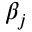Convert formula to latex. <formula><loc_0><loc_0><loc_500><loc_500>\beta _ { j }</formula> 